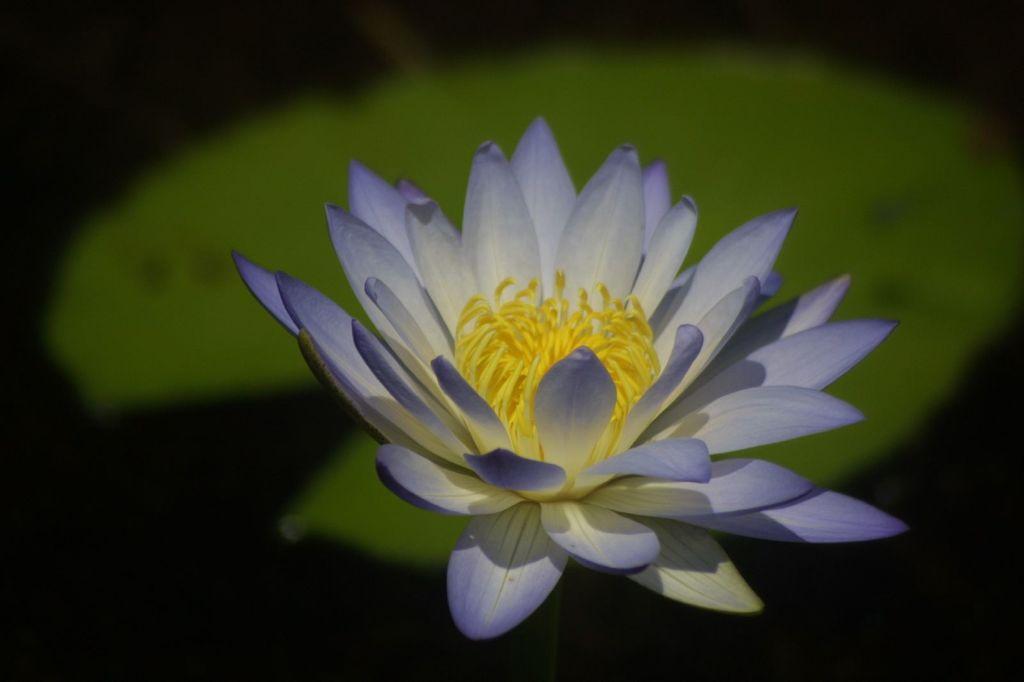Please provide a concise description of this image. In this image we can see one blue lotus with leaf and there is a dark background. 